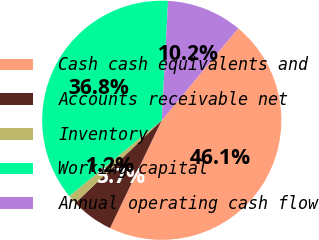Convert chart to OTSL. <chart><loc_0><loc_0><loc_500><loc_500><pie_chart><fcel>Cash cash equivalents and<fcel>Accounts receivable net<fcel>Inventory<fcel>Working capital<fcel>Annual operating cash flow<nl><fcel>46.08%<fcel>5.72%<fcel>1.23%<fcel>36.77%<fcel>10.2%<nl></chart> 